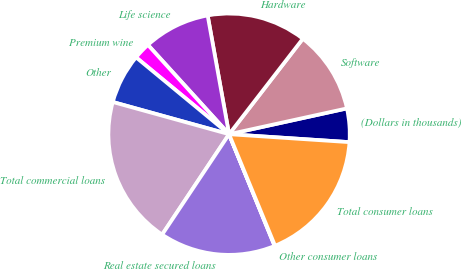Convert chart to OTSL. <chart><loc_0><loc_0><loc_500><loc_500><pie_chart><fcel>(Dollars in thousands)<fcel>Software<fcel>Hardware<fcel>Life science<fcel>Premium wine<fcel>Other<fcel>Total commercial loans<fcel>Real estate secured loans<fcel>Other consumer loans<fcel>Total consumer loans<nl><fcel>4.48%<fcel>11.1%<fcel>13.31%<fcel>8.9%<fcel>2.27%<fcel>6.69%<fcel>19.94%<fcel>15.52%<fcel>0.06%<fcel>17.73%<nl></chart> 